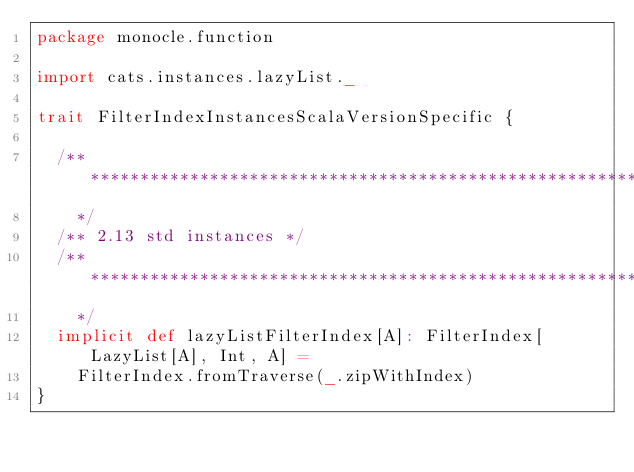Convert code to text. <code><loc_0><loc_0><loc_500><loc_500><_Scala_>package monocle.function

import cats.instances.lazyList._

trait FilterIndexInstancesScalaVersionSpecific {

  /** *********************************************************************************************
    */
  /** 2.13 std instances */
  /** *********************************************************************************************
    */
  implicit def lazyListFilterIndex[A]: FilterIndex[LazyList[A], Int, A] =
    FilterIndex.fromTraverse(_.zipWithIndex)
}
</code> 